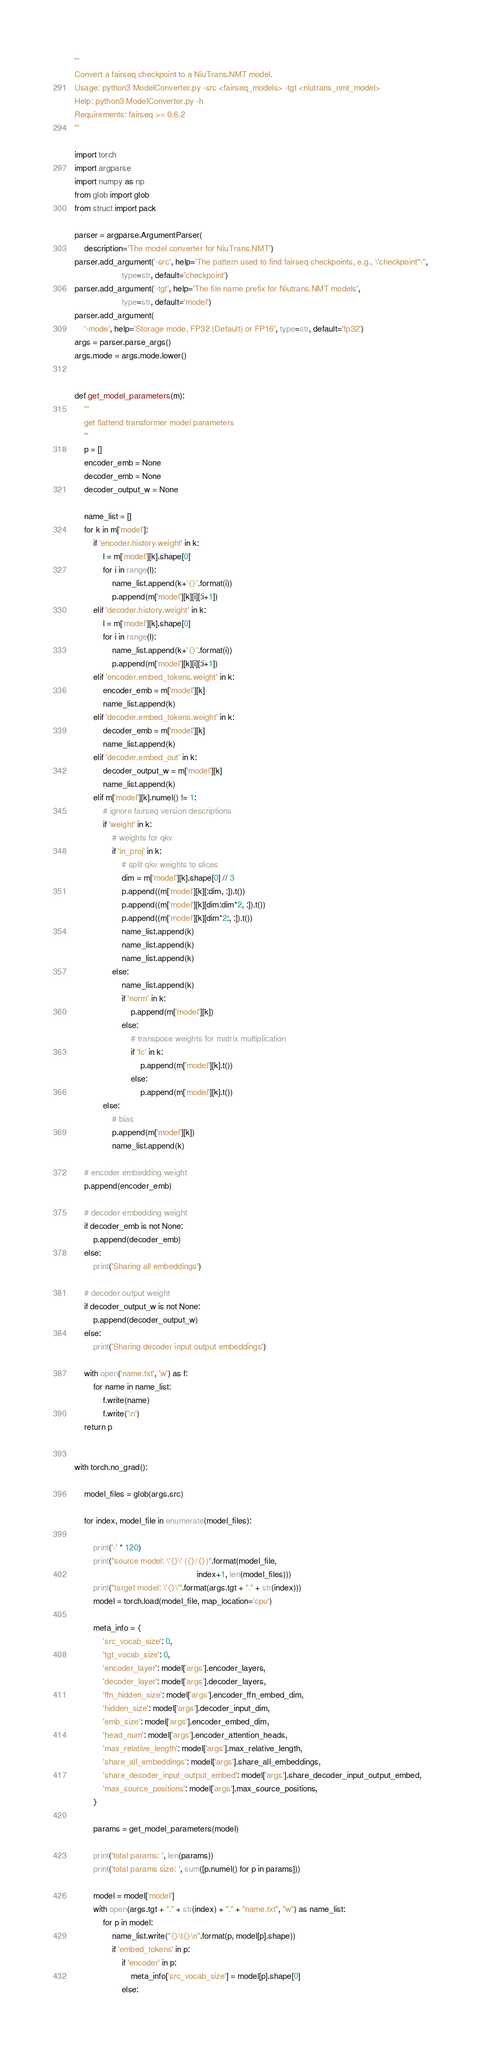<code> <loc_0><loc_0><loc_500><loc_500><_Python_>'''
Convert a fairseq checkpoint to a NiuTrans.NMT model.
Usage: python3 ModelConverter.py -src <fairseq_models> -tgt <niutrans_nmt_model>
Help: python3 ModelConverter.py -h
Requirements: fairseq >= 0.6.2
'''

import torch
import argparse
import numpy as np
from glob import glob
from struct import pack

parser = argparse.ArgumentParser(
    description='The model converter for NiuTrans.NMT')
parser.add_argument('-src', help='The pattern used to find fairseq checkpoints, e.g., \'checkpoint*\'',
                    type=str, default='checkpoint')
parser.add_argument('-tgt', help='The file name prefix for Niutrans.NMT models',
                    type=str, default='model')
parser.add_argument(
    '-mode', help='Storage mode, FP32 (Default) or FP16', type=str, default='fp32')
args = parser.parse_args()
args.mode = args.mode.lower()


def get_model_parameters(m):
    '''
    get flattend transformer model parameters
    '''
    p = []
    encoder_emb = None
    decoder_emb = None
    decoder_output_w = None

    name_list = []
    for k in m['model']:
        if 'encoder.history.weight' in k:
            l = m['model'][k].shape[0]
            for i in range(l):
                name_list.append(k+'{}'.format(i))
                p.append(m['model'][k][i][:i+1])
        elif 'decoder.history.weight' in k:
            l = m['model'][k].shape[0]
            for i in range(l):
                name_list.append(k+'{}'.format(i))
                p.append(m['model'][k][i][:i+1])
        elif 'encoder.embed_tokens.weight' in k:
            encoder_emb = m['model'][k]
            name_list.append(k)
        elif 'decoder.embed_tokens.weight' in k:
            decoder_emb = m['model'][k]
            name_list.append(k)
        elif 'decoder.embed_out' in k:
            decoder_output_w = m['model'][k]
            name_list.append(k)
        elif m['model'][k].numel() != 1:
            # ignore fairseq version descriptions
            if 'weight' in k:
                # weights for qkv
                if 'in_proj' in k:
                    # split qkv weights to slices
                    dim = m['model'][k].shape[0] // 3
                    p.append((m['model'][k][:dim, :]).t())
                    p.append((m['model'][k][dim:dim*2, :]).t())
                    p.append((m['model'][k][dim*2:, :]).t())
                    name_list.append(k)
                    name_list.append(k)
                    name_list.append(k)
                else:
                    name_list.append(k)
                    if 'norm' in k:
                        p.append(m['model'][k])
                    else:
                        # transpose weights for matrix multiplication
                        if 'fc' in k:
                            p.append(m['model'][k].t())
                        else:
                            p.append(m['model'][k].t())
            else:
                # bias
                p.append(m['model'][k])
                name_list.append(k)

    # encoder embedding weight
    p.append(encoder_emb)

    # decoder embedding weight
    if decoder_emb is not None:
        p.append(decoder_emb)
    else:
        print('Sharing all embeddings')

    # decoder output weight
    if decoder_output_w is not None:
        p.append(decoder_output_w)
    else:
        print('Sharing decoder input output embeddings')

    with open('name.txt', 'w') as f:
        for name in name_list:
            f.write(name)
            f.write('\n')
    return p


with torch.no_grad():

    model_files = glob(args.src)

    for index, model_file in enumerate(model_files):

        print('-' * 120)
        print("source model: \'{}\' ({}/{})".format(model_file,
                                                    index+1, len(model_files)))
        print("target model: \'{}\'".format(args.tgt + "." + str(index)))
        model = torch.load(model_file, map_location='cpu')

        meta_info = {
            'src_vocab_size': 0,
            'tgt_vocab_size': 0,
            'encoder_layer': model['args'].encoder_layers,
            'decoder_layer': model['args'].decoder_layers,
            'ffn_hidden_size': model['args'].encoder_ffn_embed_dim,
            'hidden_size': model['args'].decoder_input_dim,
            'emb_size': model['args'].encoder_embed_dim,
            'head_num': model['args'].encoder_attention_heads,
            'max_relative_length': model['args'].max_relative_length,
            'share_all_embeddings': model['args'].share_all_embeddings,
            'share_decoder_input_output_embed': model['args'].share_decoder_input_output_embed,
            'max_source_positions': model['args'].max_source_positions,
        }

        params = get_model_parameters(model)

        print('total params: ', len(params))
        print('total params size: ', sum([p.numel() for p in params]))

        model = model['model']
        with open(args.tgt + "." + str(index) + "." + "name.txt", "w") as name_list:
            for p in model:
                name_list.write("{}\t{}\n".format(p, model[p].shape))
                if 'embed_tokens' in p:
                    if 'encoder' in p:
                        meta_info['src_vocab_size'] = model[p].shape[0]
                    else:</code> 